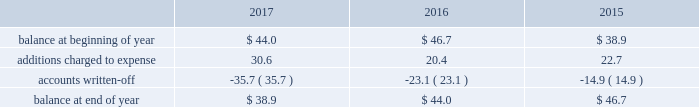Republic services , inc .
Notes to consolidated financial statements 2014 ( continued ) high quality financial institutions .
Such balances may be in excess of fdic insured limits .
To manage the related credit exposure , we continually monitor the credit worthiness of the financial institutions where we have deposits .
Concentrations of credit risk with respect to trade accounts receivable are limited due to the wide variety of customers and markets in which we provide services , as well as the dispersion of our operations across many geographic areas .
We provide services to small-container , large-container , municipal and residential , and energy services customers in the united states and puerto rico .
We perform ongoing credit evaluations of our customers , but generally do not require collateral to support customer receivables .
We establish an allowance for doubtful accounts based on various factors including the credit risk of specific customers , age of receivables outstanding , historical trends , economic conditions and other information .
Accounts receivable , net accounts receivable represent receivables from customers for collection , transfer , recycling , disposal , energy services and other services .
Our receivables are recorded when billed or when the related revenue is earned , if earlier , and represent claims against third parties that will be settled in cash .
The carrying value of our receivables , net of the allowance for doubtful accounts and customer credits , represents their estimated net realizable value .
Provisions for doubtful accounts are evaluated on a monthly basis and are recorded based on our historical collection experience , the age of the receivables , specific customer information and economic conditions .
We also review outstanding balances on an account-specific basis .
In general , reserves are provided for accounts receivable in excess of 90 days outstanding .
Past due receivable balances are written-off when our collection efforts have been unsuccessful in collecting amounts due .
The table reflects the activity in our allowance for doubtful accounts for the years ended december 31: .
Restricted cash and marketable securities as of december 31 , 2017 , we had $ 141.1 million of restricted cash and marketable securities of which $ 71.4 million supports our insurance programs for workers 2019 compensation , commercial general liability , and commercial auto liability .
Additionally , we obtain funds through the issuance of tax-exempt bonds for the purpose of financing qualifying expenditures at our landfills , transfer stations , collection and recycling centers .
The funds are deposited directly into trust accounts by the bonding authorities at the time of issuance .
As the use of these funds is contractually restricted , and we do not have the ability to use these funds for general operating purposes , they are classified as restricted cash and marketable securities in our consolidated balance sheets .
In the normal course of business , we may be required to provide financial assurance to governmental agencies and a variety of other entities in connection with municipal residential collection contracts , closure or post- closure of landfills , environmental remediation , environmental permits , and business licenses and permits as a financial guarantee of our performance .
At several of our landfills , we satisfy financial assurance requirements by depositing cash into restricted trust funds or escrow accounts .
Property and equipment we record property and equipment at cost .
Expenditures for major additions and improvements to facilities are capitalized , while maintenance and repairs are charged to expense as incurred .
When property is retired or .
What was the percent of the decline in the account balance in the allowance for doubtful accounts from 2016 to 2017? 
Rationale: the decline in the account balance in the allowance for doubtful accounts was -5.8%
Computations: ((44.0 - 46.7) / 46.7)
Answer: -0.05782. 